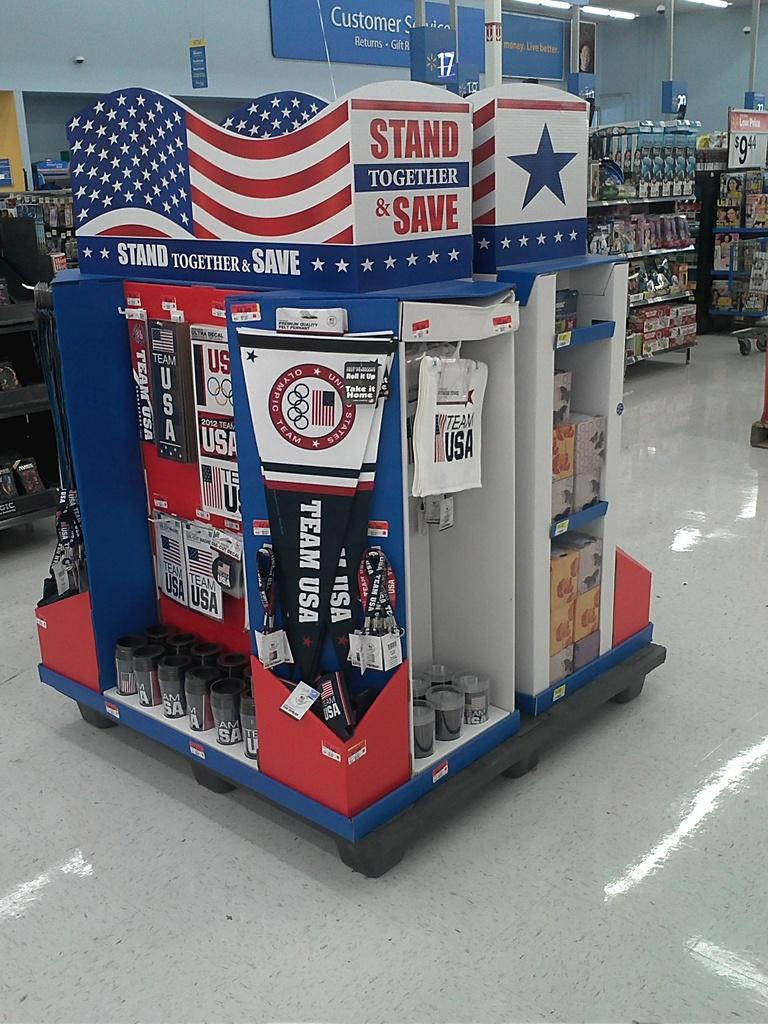What is the first word in red on the sign?
Offer a terse response. Stand. What shop is this in?
Your response must be concise. Walmart. 